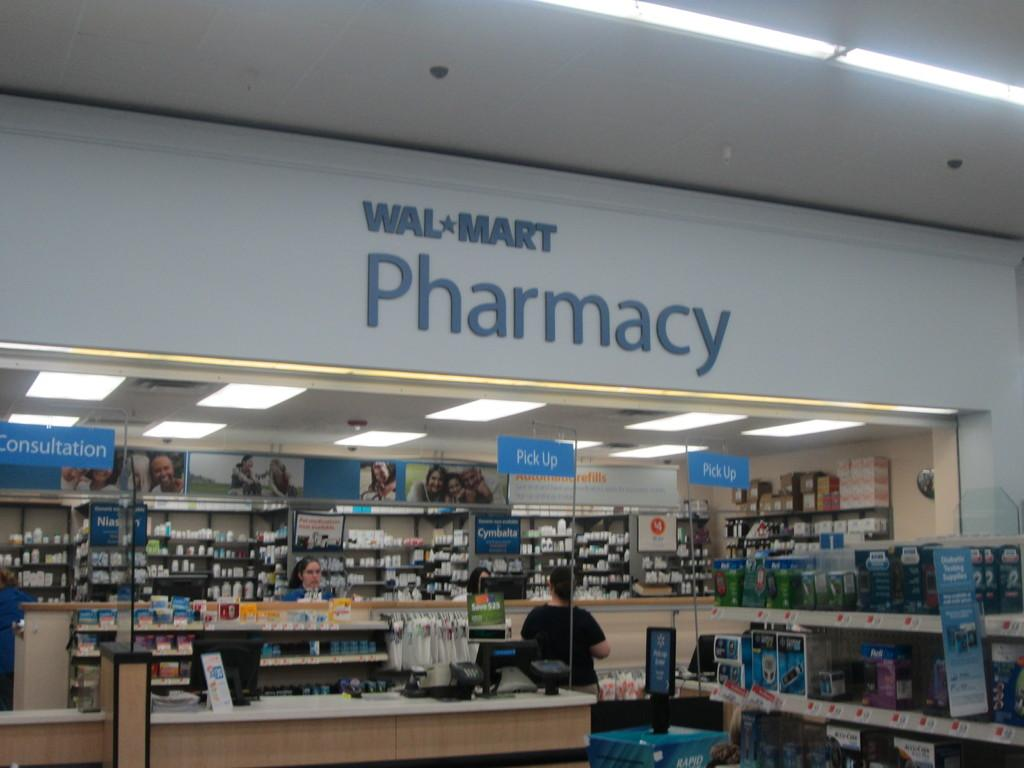<image>
Render a clear and concise summary of the photo. a wal mart pharmacy with a person standing under the sign 